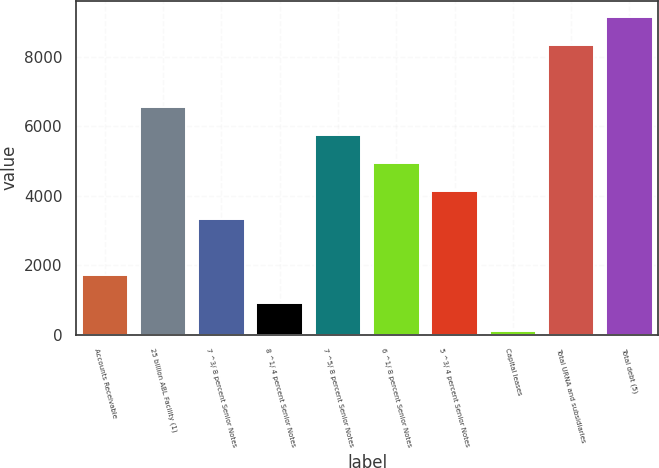Convert chart. <chart><loc_0><loc_0><loc_500><loc_500><bar_chart><fcel>Accounts Receivable<fcel>25 billion ABL Facility (1)<fcel>7 ^3/ 8 percent Senior Notes<fcel>8 ^1/ 4 percent Senior Notes<fcel>7 ^5/ 8 percent Senior Notes<fcel>6 ^1/ 8 percent Senior Notes<fcel>5 ^3/ 4 percent Senior Notes<fcel>Capital leases<fcel>Total URNA and subsidiaries<fcel>Total debt (5)<nl><fcel>1709.2<fcel>6548.8<fcel>3322.4<fcel>902.6<fcel>5742.2<fcel>4935.6<fcel>4129<fcel>96<fcel>8361.6<fcel>9168.2<nl></chart> 